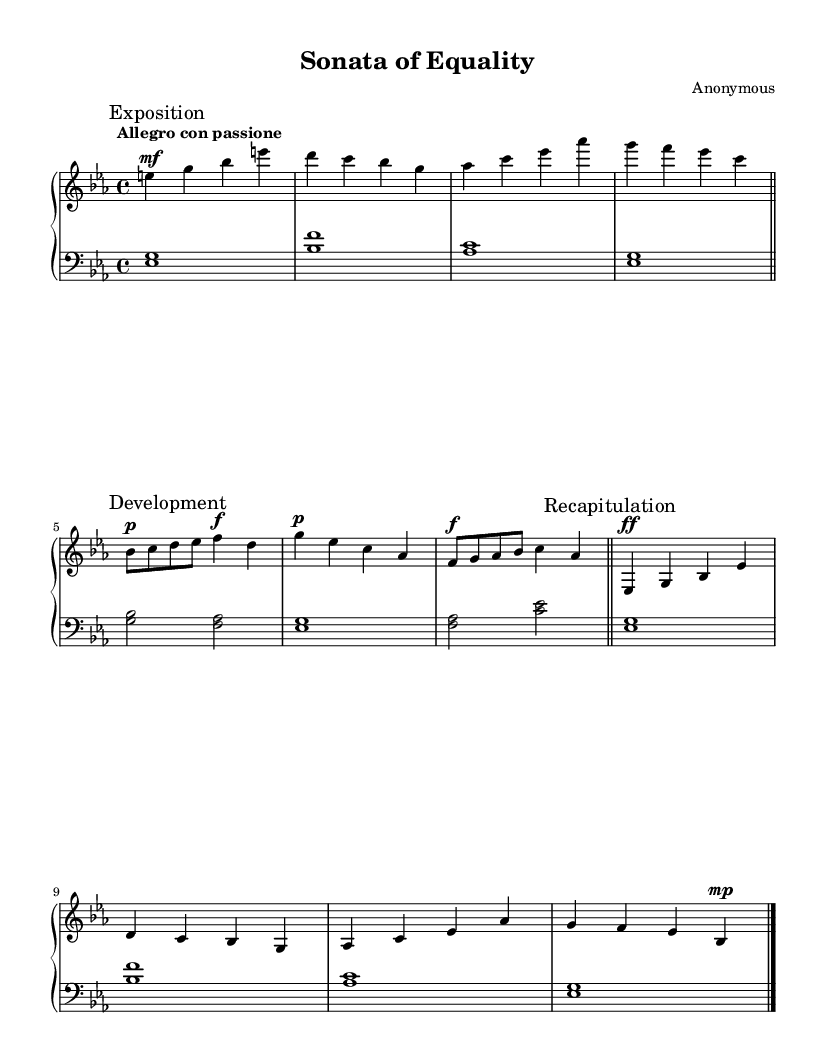What is the key signature of this music? The key signature is E-flat major, which includes three flats: B-flat, E-flat, and A-flat. This can be observed from the beginning of the sheet music where the flats are placed.
Answer: E-flat major What is the time signature of this music? The time signature is 4/4, meaning there are four beats in each measure and the quarter note gets one beat. This can be seen at the beginning of the score just after the key signature.
Answer: 4/4 What is the tempo marking of the piece? The tempo marking is "Allegro con passione," which indicates a lively tempo with passion. This is specified in the first line of the music sheet, guiding the performers on how to play the piece.
Answer: Allegro con passione How many main sections are present in the piece? There are three main sections in the piece: Exposition, Development, and Recapitulation. Each section is clearly marked in the sheet music, making it easy to identify the structure of the composition.
Answer: Three In which section do we find the dynamic marking "ff"? The dynamic marking "ff" appears in the Development section of the piece. This section is indicated in the music, and the "ff" marking is placed above the notes to indicate a very loud volume at that moment.
Answer: Development 